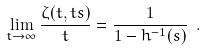Convert formula to latex. <formula><loc_0><loc_0><loc_500><loc_500>\lim _ { t \to \infty } \frac { \zeta ( t , t s ) } { t } = \frac { 1 } { 1 - h ^ { - 1 } ( s ) } \ .</formula> 